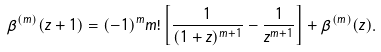Convert formula to latex. <formula><loc_0><loc_0><loc_500><loc_500>\beta ^ { ( m ) } ( z + 1 ) = ( - 1 ) ^ { m } m ! \left [ \frac { 1 } { ( 1 + z ) ^ { m + 1 } } - \frac { 1 } { z ^ { m + 1 } } \right ] + \beta ^ { ( m ) } ( z ) .</formula> 